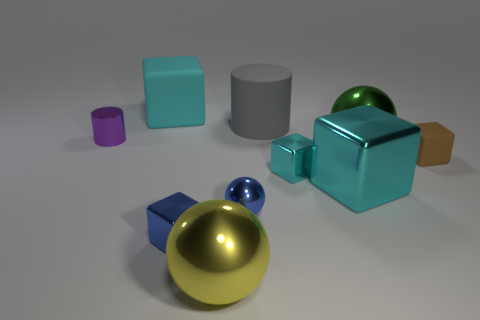How many objects are balls in front of the brown matte thing or tiny red matte spheres?
Your response must be concise. 2. There is another metallic thing that is the same shape as the large gray thing; what color is it?
Provide a short and direct response. Purple. There is a small brown object; is its shape the same as the shiny object that is right of the large cyan metallic cube?
Provide a succinct answer. No. How many objects are either tiny things on the left side of the large green thing or cyan objects that are in front of the big cyan rubber thing?
Provide a short and direct response. 5. Is the number of big shiny blocks in front of the big cylinder less than the number of small metal cubes?
Offer a very short reply. Yes. Is the tiny blue block made of the same material as the big cube that is on the left side of the large cylinder?
Your answer should be very brief. No. What is the material of the large gray cylinder?
Your answer should be compact. Rubber. There is a cyan thing that is left of the blue metal thing to the left of the big sphere left of the big cyan metal object; what is its material?
Make the answer very short. Rubber. Do the small ball and the shiny block that is left of the tiny cyan metal thing have the same color?
Your answer should be compact. Yes. What is the color of the large cube in front of the purple shiny cylinder that is behind the small brown matte block?
Your answer should be very brief. Cyan. 